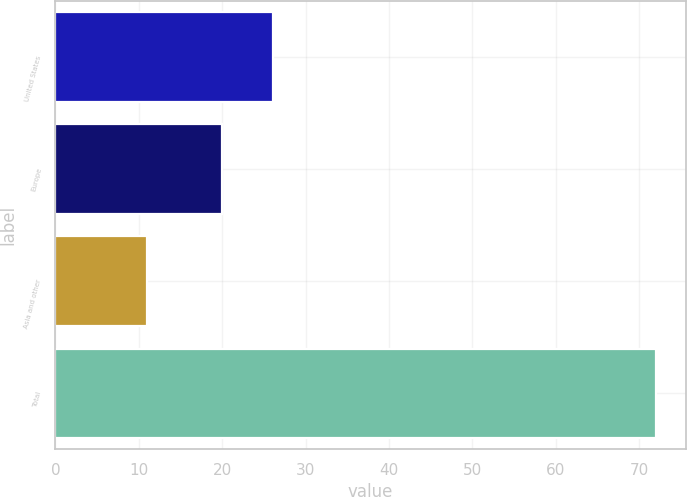Convert chart. <chart><loc_0><loc_0><loc_500><loc_500><bar_chart><fcel>United States<fcel>Europe<fcel>Asia and other<fcel>Total<nl><fcel>26.1<fcel>20<fcel>11<fcel>72<nl></chart> 